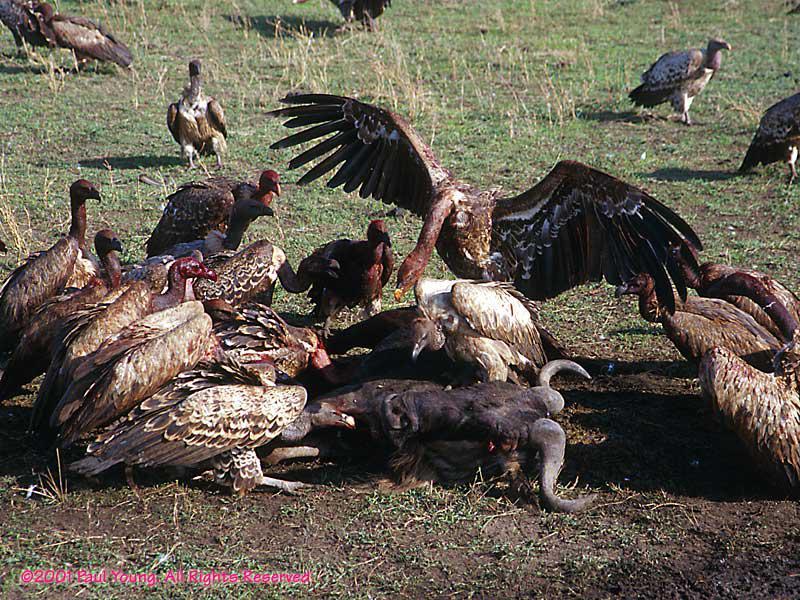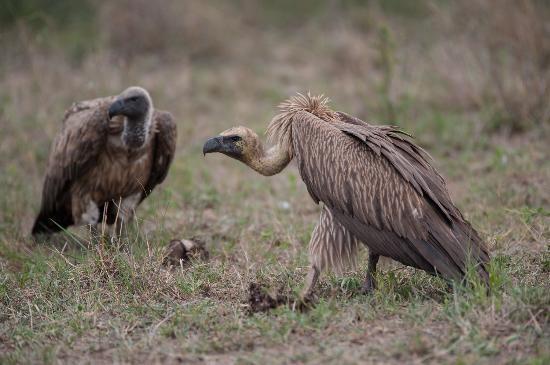The first image is the image on the left, the second image is the image on the right. For the images displayed, is the sentence "An image contains exactly two vultures, neither with spread wings." factually correct? Answer yes or no. Yes. 